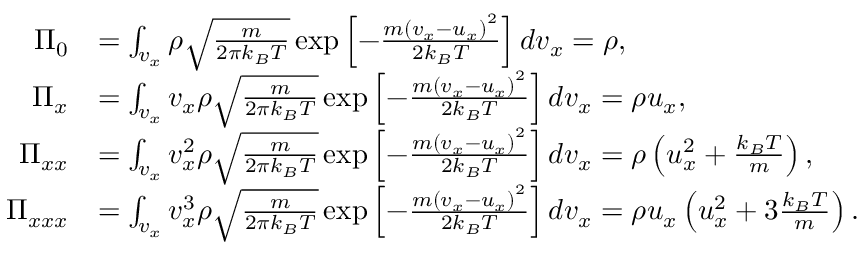Convert formula to latex. <formula><loc_0><loc_0><loc_500><loc_500>\begin{array} { r l } { \Pi _ { 0 } } & { = \int _ { v _ { x } } \rho \sqrt { \frac { m } { 2 \pi k _ { B } T } } \exp \left [ { - \frac { m { ( v _ { x } - u _ { x } ) } ^ { 2 } } { 2 k _ { B } T } } \right ] d v _ { x } = \rho , } \\ { \Pi _ { x } } & { = \int _ { v _ { x } } v _ { x } \rho \sqrt { \frac { m } { 2 \pi k _ { B } T } } \exp \left [ { - \frac { m { ( v _ { x } - u _ { x } ) } ^ { 2 } } { 2 k _ { B } T } } \right ] d v _ { x } = \rho u _ { x } , } \\ { \Pi _ { x x } } & { = \int _ { v _ { x } } v _ { x } ^ { 2 } \rho \sqrt { \frac { m } { 2 \pi k _ { B } T } } \exp \left [ { - \frac { m { ( v _ { x } - u _ { x } ) } ^ { 2 } } { 2 k _ { B } T } } \right ] d v _ { x } = \rho \left ( u _ { x } ^ { 2 } + \frac { k _ { B } T } { m } \right ) , } \\ { \Pi _ { x x x } } & { = \int _ { v _ { x } } v _ { x } ^ { 3 } \rho \sqrt { \frac { m } { 2 \pi k _ { B } T } } \exp \left [ { - \frac { m { ( v _ { x } - u _ { x } ) } ^ { 2 } } { 2 k _ { B } T } } \right ] d v _ { x } = \rho u _ { x } \left ( u _ { x } ^ { 2 } + 3 \frac { k _ { B } T } { m } \right ) . } \end{array}</formula> 